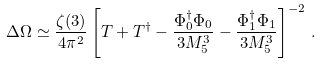<formula> <loc_0><loc_0><loc_500><loc_500>\Delta \Omega \simeq \frac { \zeta ( 3 ) } { 4 \pi ^ { 2 } } \left [ T + T ^ { \dagger } - \frac { \Phi _ { 0 } ^ { \dagger } \Phi _ { 0 } } { 3 M _ { 5 } ^ { 3 } } - \frac { \Phi _ { 1 } ^ { \dagger } \Phi _ { 1 } } { 3 M _ { 5 } ^ { 3 } } \right ] ^ { - 2 } \, .</formula> 